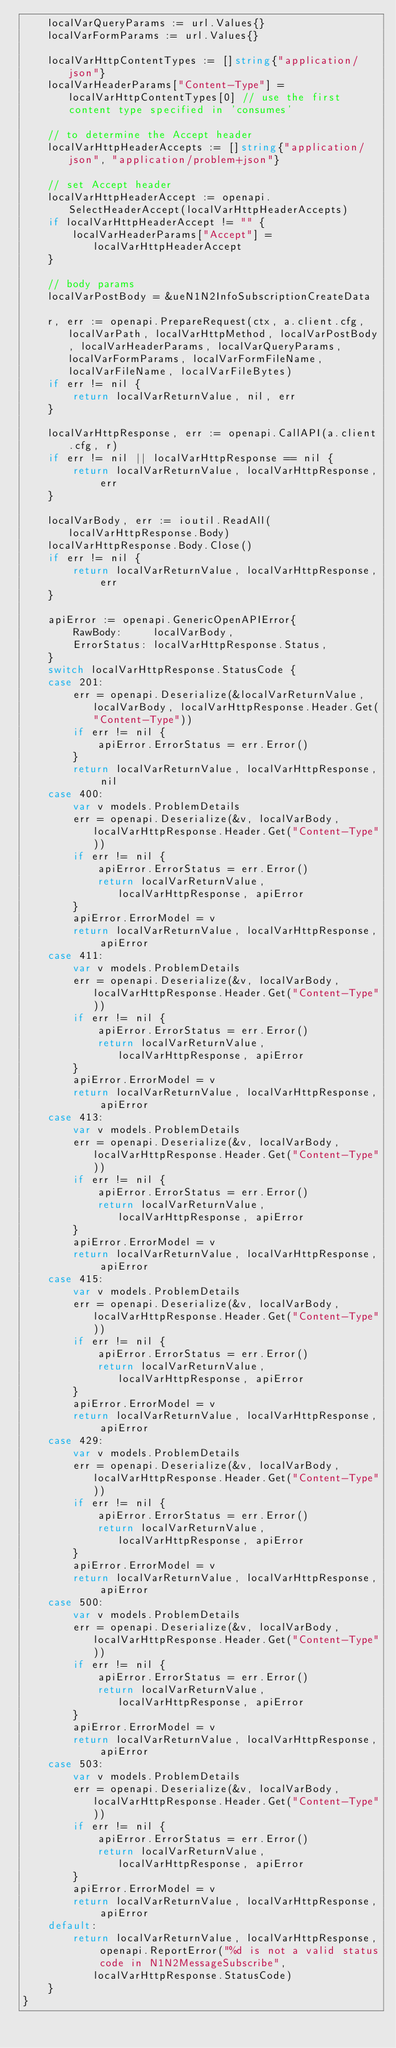<code> <loc_0><loc_0><loc_500><loc_500><_Go_>	localVarQueryParams := url.Values{}
	localVarFormParams := url.Values{}

	localVarHttpContentTypes := []string{"application/json"}
	localVarHeaderParams["Content-Type"] = localVarHttpContentTypes[0] // use the first content type specified in 'consumes'

	// to determine the Accept header
	localVarHttpHeaderAccepts := []string{"application/json", "application/problem+json"}

	// set Accept header
	localVarHttpHeaderAccept := openapi.SelectHeaderAccept(localVarHttpHeaderAccepts)
	if localVarHttpHeaderAccept != "" {
		localVarHeaderParams["Accept"] = localVarHttpHeaderAccept
	}

	// body params
	localVarPostBody = &ueN1N2InfoSubscriptionCreateData

	r, err := openapi.PrepareRequest(ctx, a.client.cfg, localVarPath, localVarHttpMethod, localVarPostBody, localVarHeaderParams, localVarQueryParams, localVarFormParams, localVarFormFileName, localVarFileName, localVarFileBytes)
	if err != nil {
		return localVarReturnValue, nil, err
	}

	localVarHttpResponse, err := openapi.CallAPI(a.client.cfg, r)
	if err != nil || localVarHttpResponse == nil {
		return localVarReturnValue, localVarHttpResponse, err
	}

	localVarBody, err := ioutil.ReadAll(localVarHttpResponse.Body)
	localVarHttpResponse.Body.Close()
	if err != nil {
		return localVarReturnValue, localVarHttpResponse, err
	}

	apiError := openapi.GenericOpenAPIError{
		RawBody:     localVarBody,
		ErrorStatus: localVarHttpResponse.Status,
	}
	switch localVarHttpResponse.StatusCode {
	case 201:
		err = openapi.Deserialize(&localVarReturnValue, localVarBody, localVarHttpResponse.Header.Get("Content-Type"))
		if err != nil {
			apiError.ErrorStatus = err.Error()
		}
		return localVarReturnValue, localVarHttpResponse, nil
	case 400:
		var v models.ProblemDetails
		err = openapi.Deserialize(&v, localVarBody, localVarHttpResponse.Header.Get("Content-Type"))
		if err != nil {
			apiError.ErrorStatus = err.Error()
			return localVarReturnValue, localVarHttpResponse, apiError
		}
		apiError.ErrorModel = v
		return localVarReturnValue, localVarHttpResponse, apiError
	case 411:
		var v models.ProblemDetails
		err = openapi.Deserialize(&v, localVarBody, localVarHttpResponse.Header.Get("Content-Type"))
		if err != nil {
			apiError.ErrorStatus = err.Error()
			return localVarReturnValue, localVarHttpResponse, apiError
		}
		apiError.ErrorModel = v
		return localVarReturnValue, localVarHttpResponse, apiError
	case 413:
		var v models.ProblemDetails
		err = openapi.Deserialize(&v, localVarBody, localVarHttpResponse.Header.Get("Content-Type"))
		if err != nil {
			apiError.ErrorStatus = err.Error()
			return localVarReturnValue, localVarHttpResponse, apiError
		}
		apiError.ErrorModel = v
		return localVarReturnValue, localVarHttpResponse, apiError
	case 415:
		var v models.ProblemDetails
		err = openapi.Deserialize(&v, localVarBody, localVarHttpResponse.Header.Get("Content-Type"))
		if err != nil {
			apiError.ErrorStatus = err.Error()
			return localVarReturnValue, localVarHttpResponse, apiError
		}
		apiError.ErrorModel = v
		return localVarReturnValue, localVarHttpResponse, apiError
	case 429:
		var v models.ProblemDetails
		err = openapi.Deserialize(&v, localVarBody, localVarHttpResponse.Header.Get("Content-Type"))
		if err != nil {
			apiError.ErrorStatus = err.Error()
			return localVarReturnValue, localVarHttpResponse, apiError
		}
		apiError.ErrorModel = v
		return localVarReturnValue, localVarHttpResponse, apiError
	case 500:
		var v models.ProblemDetails
		err = openapi.Deserialize(&v, localVarBody, localVarHttpResponse.Header.Get("Content-Type"))
		if err != nil {
			apiError.ErrorStatus = err.Error()
			return localVarReturnValue, localVarHttpResponse, apiError
		}
		apiError.ErrorModel = v
		return localVarReturnValue, localVarHttpResponse, apiError
	case 503:
		var v models.ProblemDetails
		err = openapi.Deserialize(&v, localVarBody, localVarHttpResponse.Header.Get("Content-Type"))
		if err != nil {
			apiError.ErrorStatus = err.Error()
			return localVarReturnValue, localVarHttpResponse, apiError
		}
		apiError.ErrorModel = v
		return localVarReturnValue, localVarHttpResponse, apiError
	default:
		return localVarReturnValue, localVarHttpResponse, openapi.ReportError("%d is not a valid status code in N1N2MessageSubscribe", localVarHttpResponse.StatusCode)
	}
}
</code> 